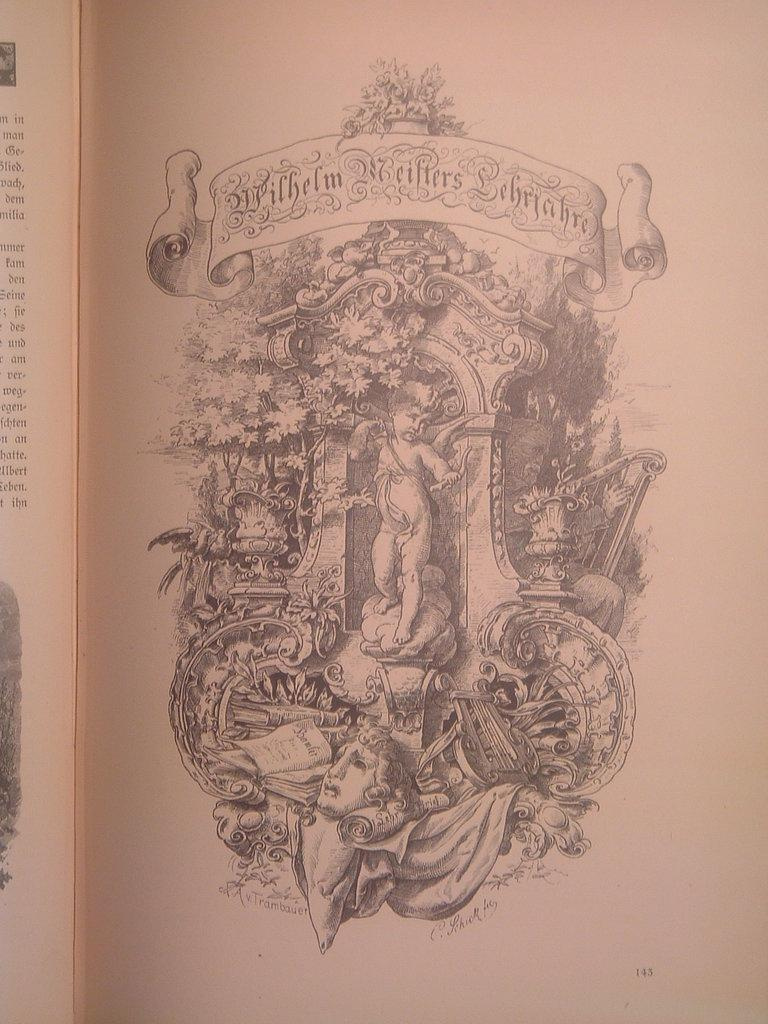What is depicted on the paper in the image? There is a picture on the paper in the image. What else can be found on the paper besides the picture? There is text on the paper in the image. What type of poison is being used to destroy the doll in the image? There is no doll or poison present in the image. The image only contains a paper with a picture and text on it. 